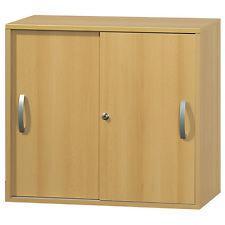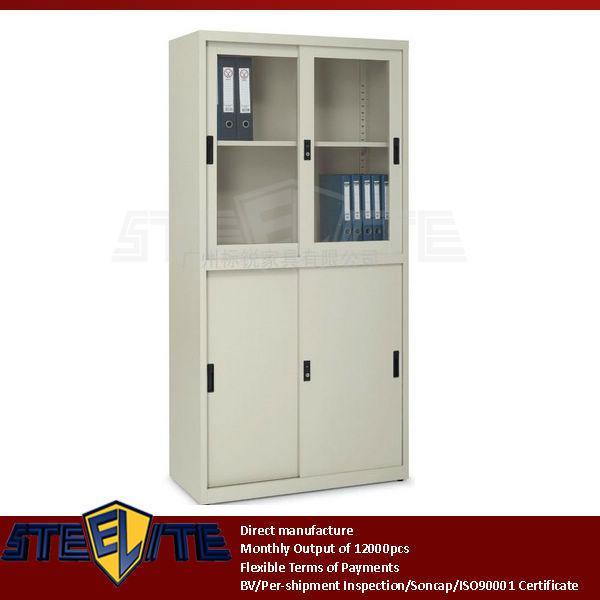The first image is the image on the left, the second image is the image on the right. Assess this claim about the two images: "In one image, at least one door panel with white frame and glass inserts is shown in an open position.". Correct or not? Answer yes or no. No. The first image is the image on the left, the second image is the image on the right. Given the left and right images, does the statement "Chairs sit near a table in a home." hold true? Answer yes or no. No. 